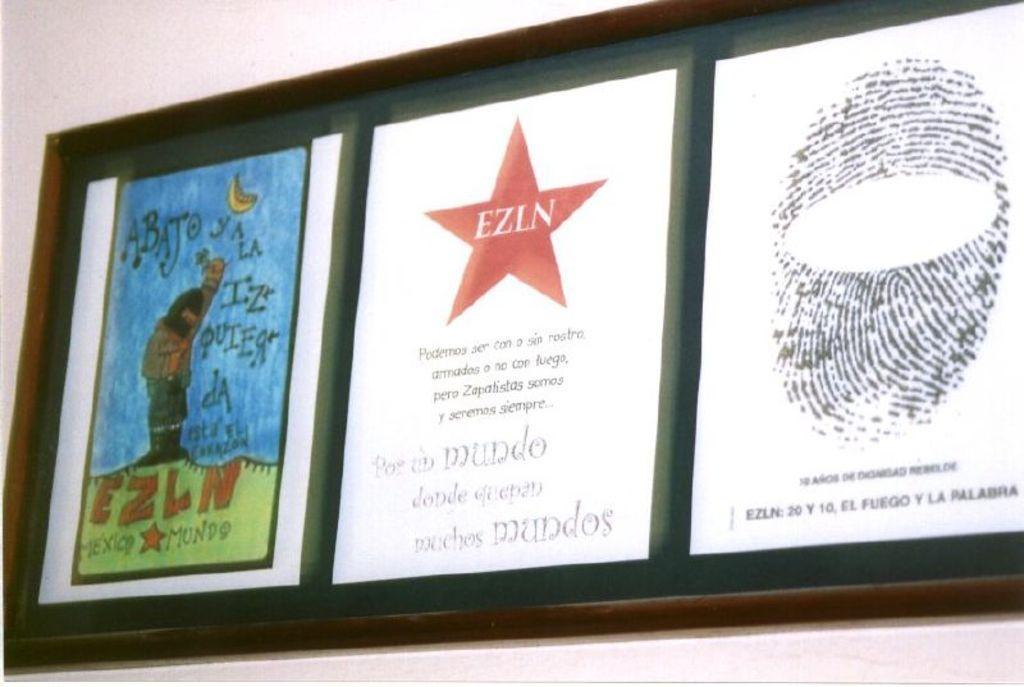Could you give a brief overview of what you see in this image? In this picture we can see a board, there are three papers pasted on the board, we can see some text on these papers, in the background there is a wall. 